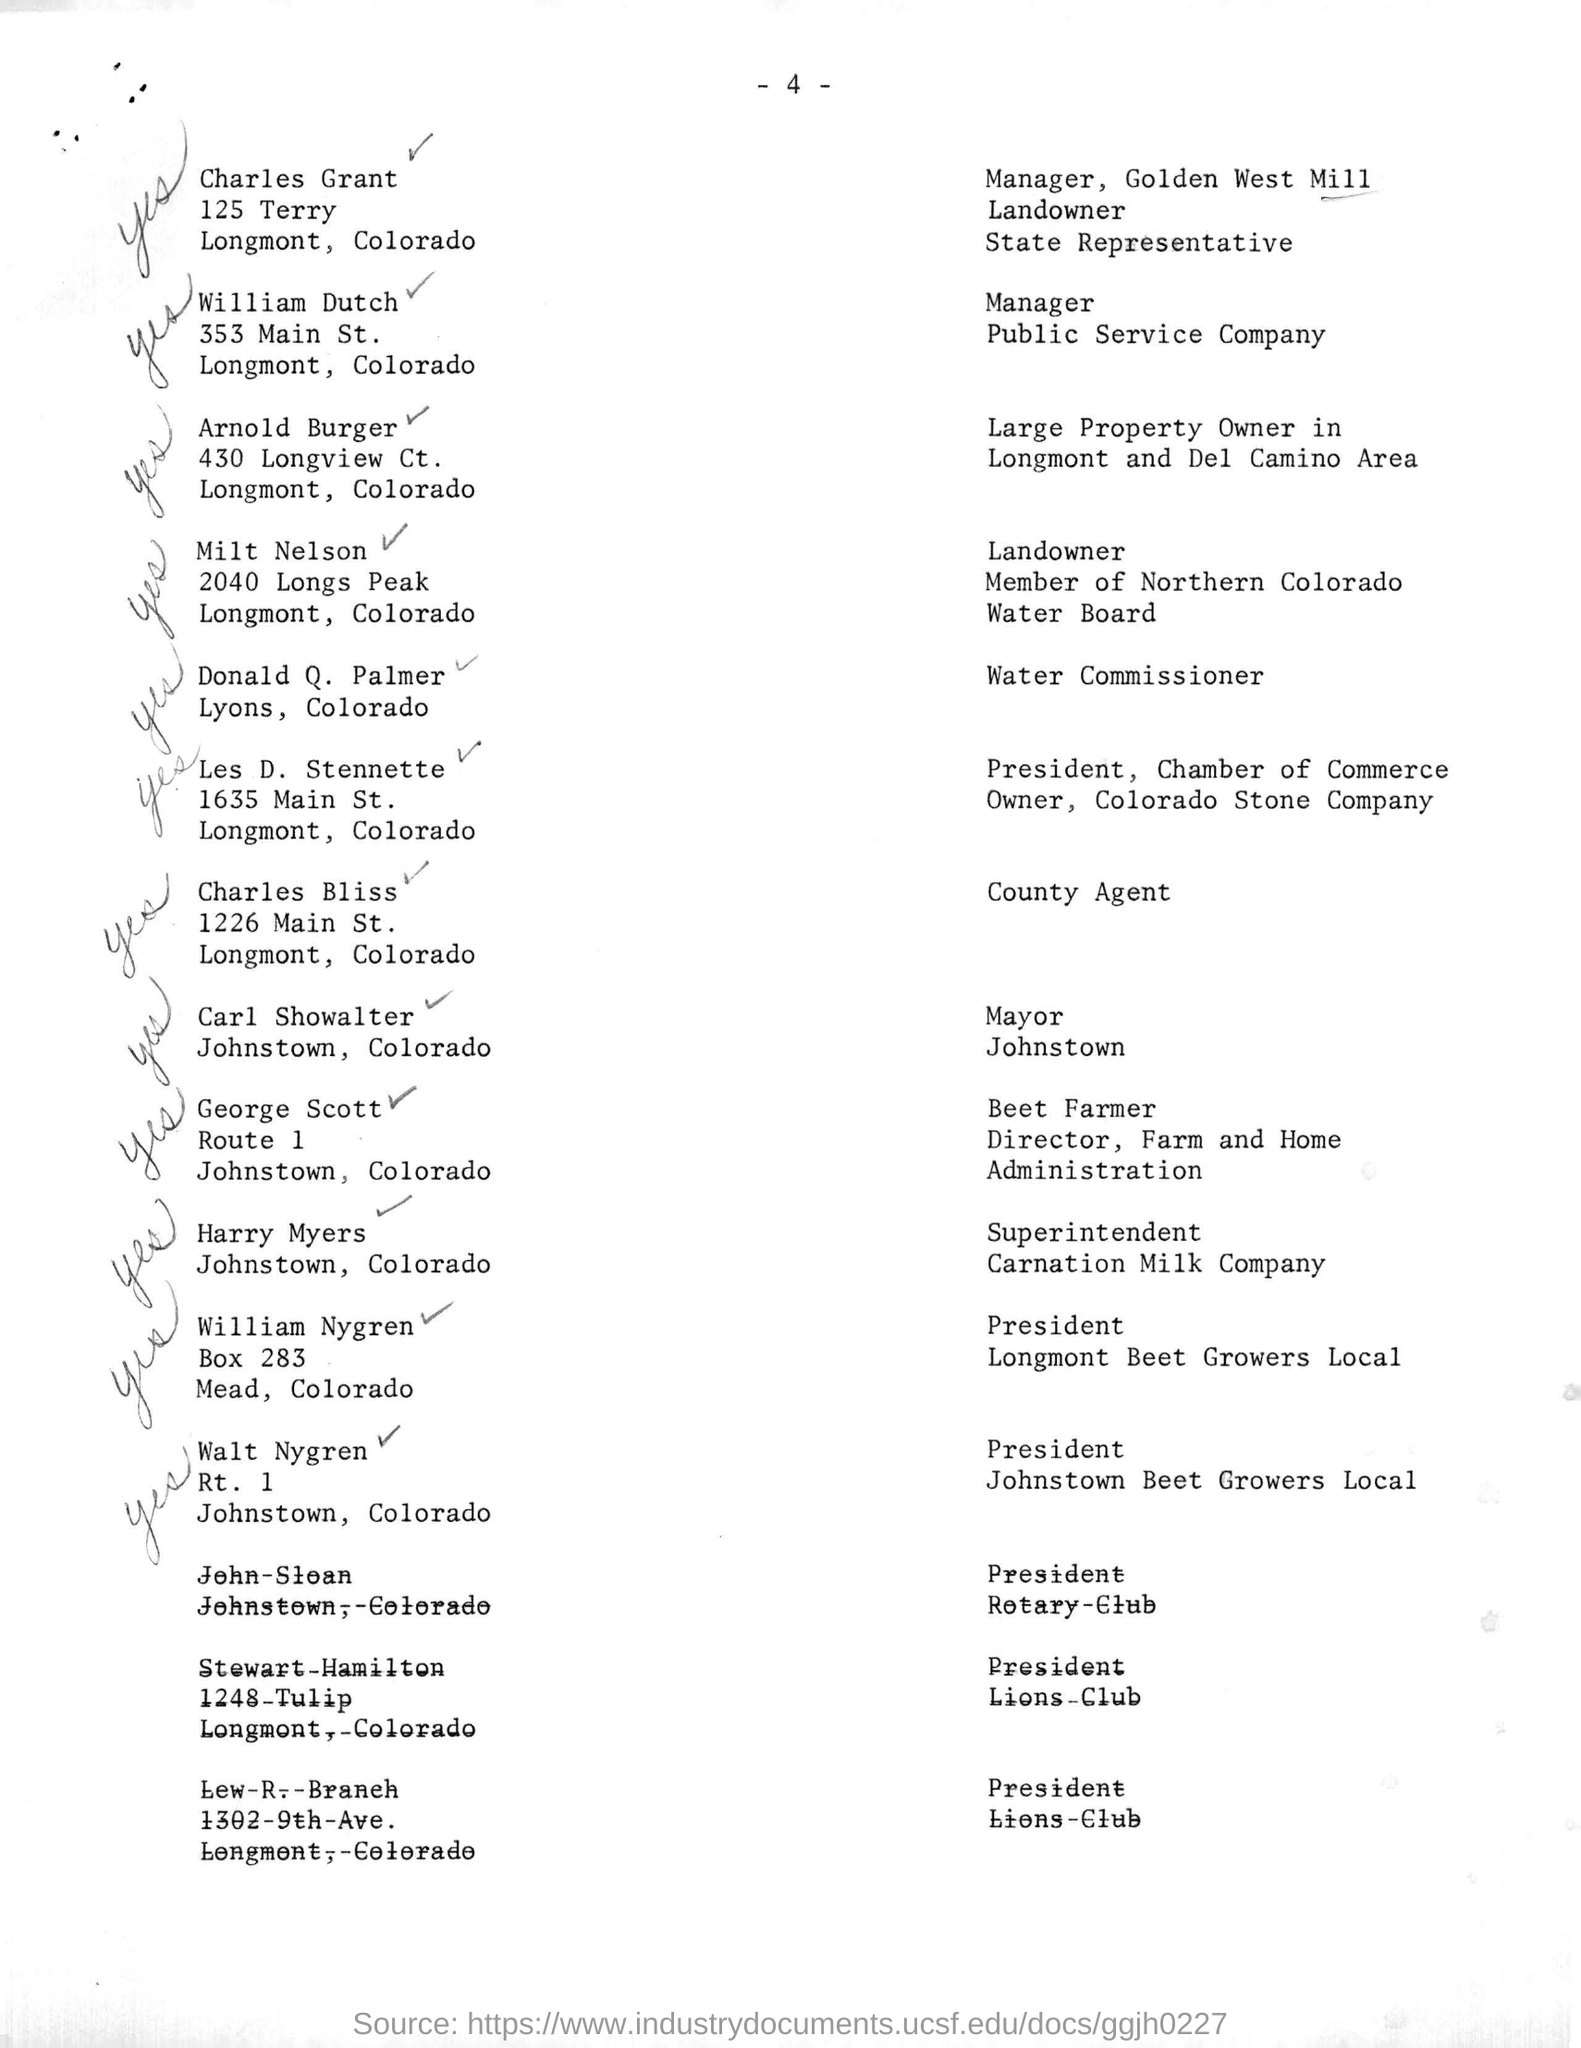Mention a couple of crucial points in this snapshot. The person identified as Country Agent is Charles Bliss. William Dutch is the manager of a public service company. The President of Longmont Beet Growers Local is William Nygren. 